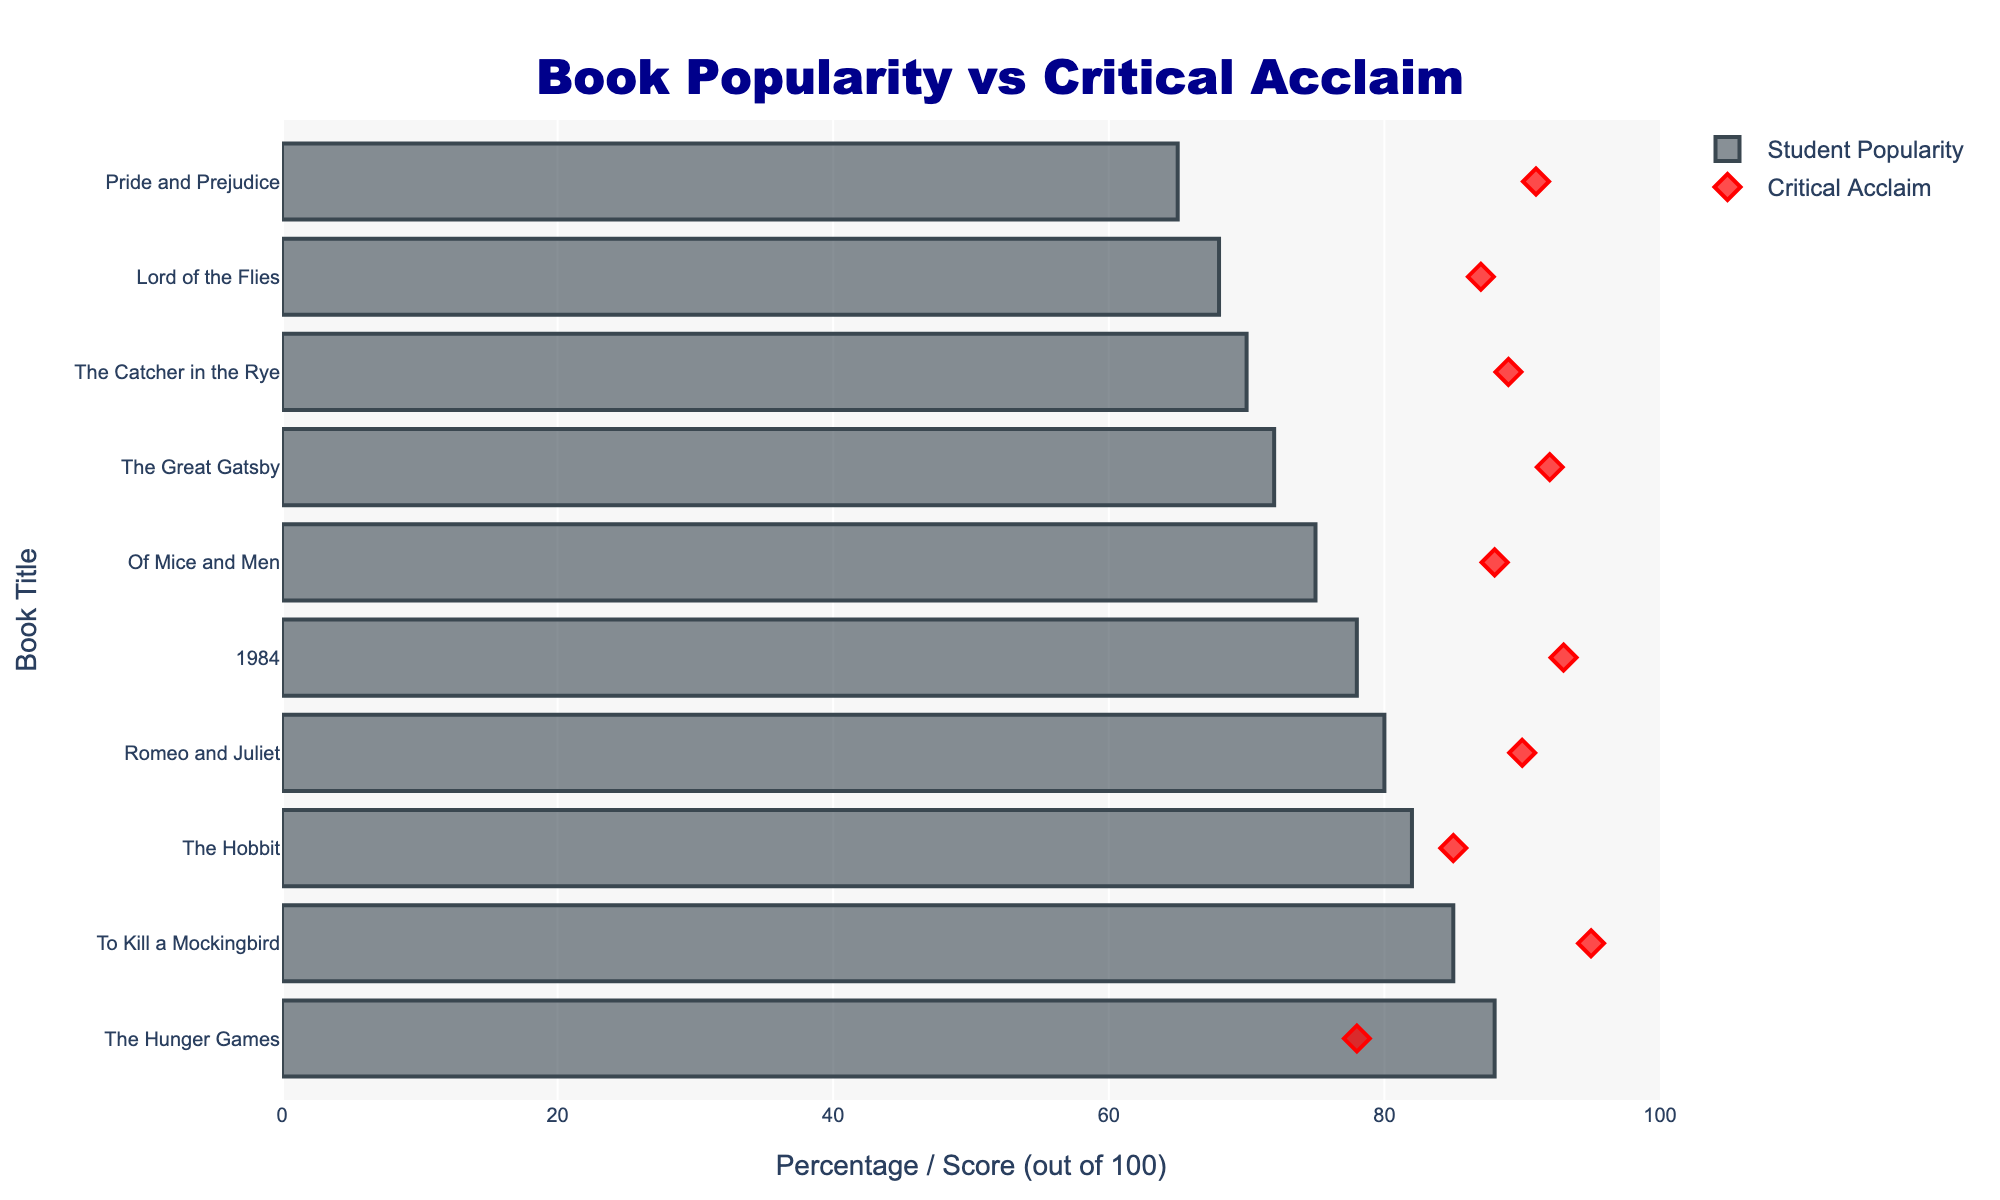What is the title of the plot? The title of the plot is displayed at the top center of the figure and reads "Book Popularity vs Critical Acclaim".
Answer: Book Popularity vs Critical Acclaim Which book has the highest Student Popularity? By observing the horizontal bars representing Student Popularity, the longest bar corresponds to "The Hunger Games" with a popularity of 88%.
Answer: The Hunger Games What is the Student Popularity of "Romeo and Juliet"? Locate "Romeo and Juliet" on the vertical axis and follow the bar horizontally to see that its Student Popularity percentage is 80%.
Answer: 80% How does "1984" compare in Student Popularity and Critical Acclaim? "1984" has a Student Popularity of 78% and a Critical Acclaim of 9.3. This can be seen by the length of the bar representing popularity and the diamond marker representing critical acclaim.
Answer: 78% popularity, 9.3 acclaim Which book has the largest gap between Student Popularity and Critical Acclaim? Compare the difference between Student Popularity and Critical Acclaim for each book. "The Hunger Games" shows the largest gap with 88% popularity and 7.8 acclaim, giving a gap of 10.2.
Answer: The Hunger Games What is the relationship between Student Popularity and Critical Acclaim for "The Great Gatsby" and "Pride and Prejudice"? "The Great Gatsby" has 72% popularity and 9.2 acclaim, while "Pride and Prejudice" has 65% popularity and 9.1 acclaim. Both books have high acclaim scores but lower popularity percentages, indicating acclaim does not always correspond to popularity.
Answer: Both have higher acclaim than popularity Which book received the highest Critical Acclaim? The highest diamond marker on the vertical axis is for "To Kill a Mockingbird" with a critical acclaim of 9.5.
Answer: To Kill a Mockingbird 